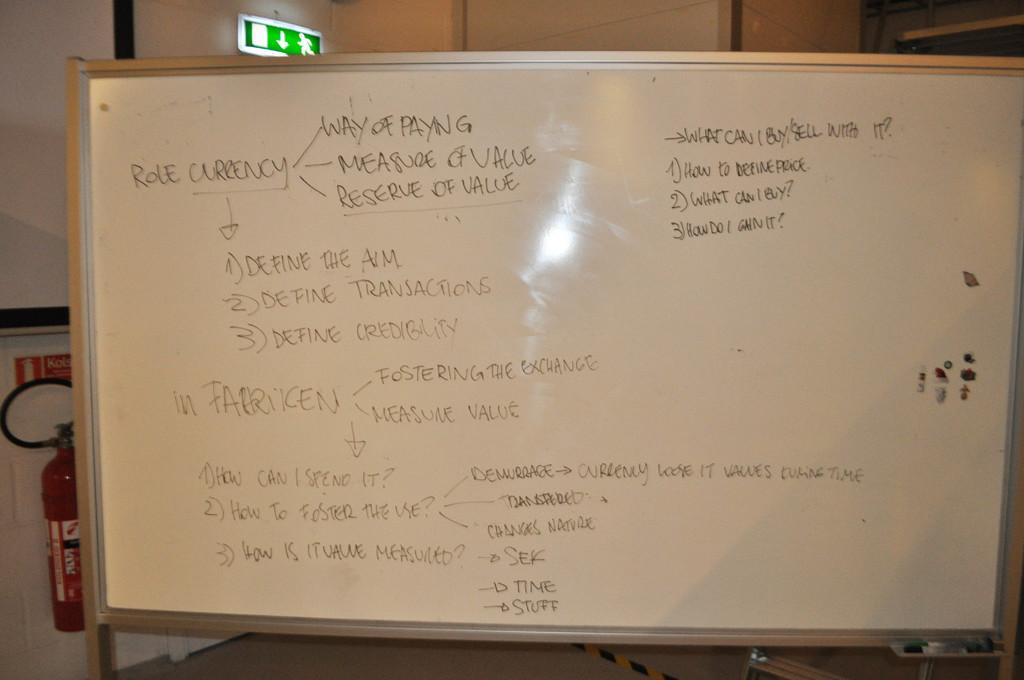What is the second question posted under the title of what can i buy/sell with it?
Offer a terse response. What can i buy. 